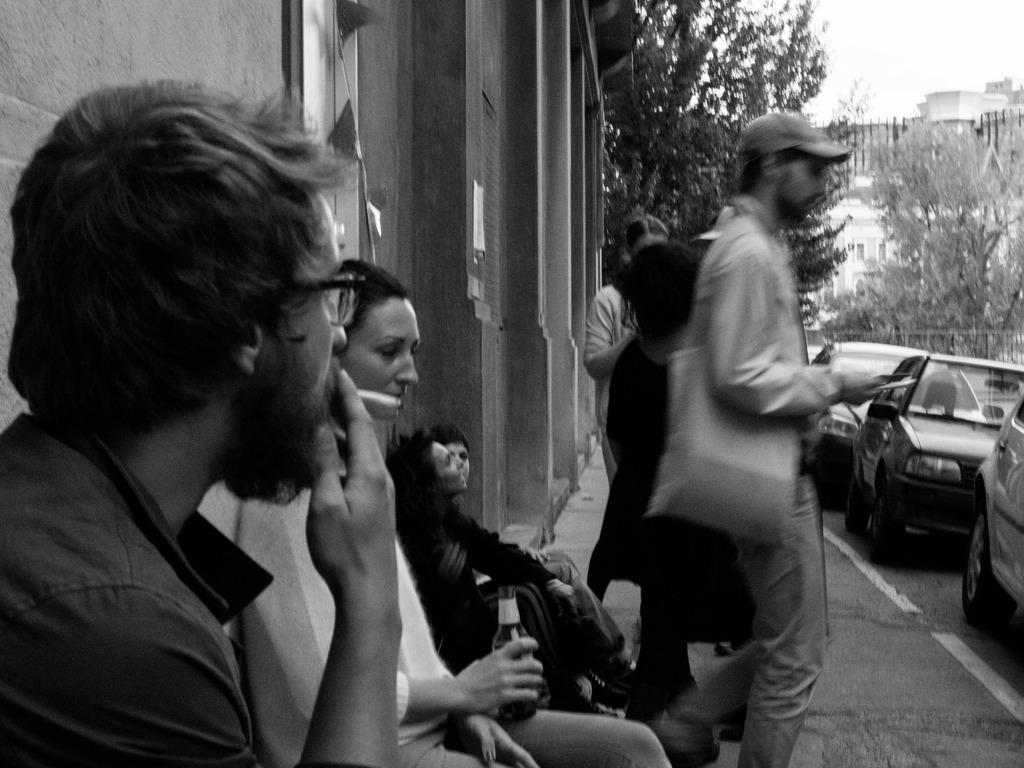In one or two sentences, can you explain what this image depicts? This is a black and white image. In the image on the left side there is a man sitting and holding a cigarette in his hand. Beside him there is a lady sitting and holding a bottle in her hand. And there are two people sitting and there are few people standing. And behind them there is a building with walls. And on the right side of the image there are cars. In the background there are trees. Behind them there are buildings. 